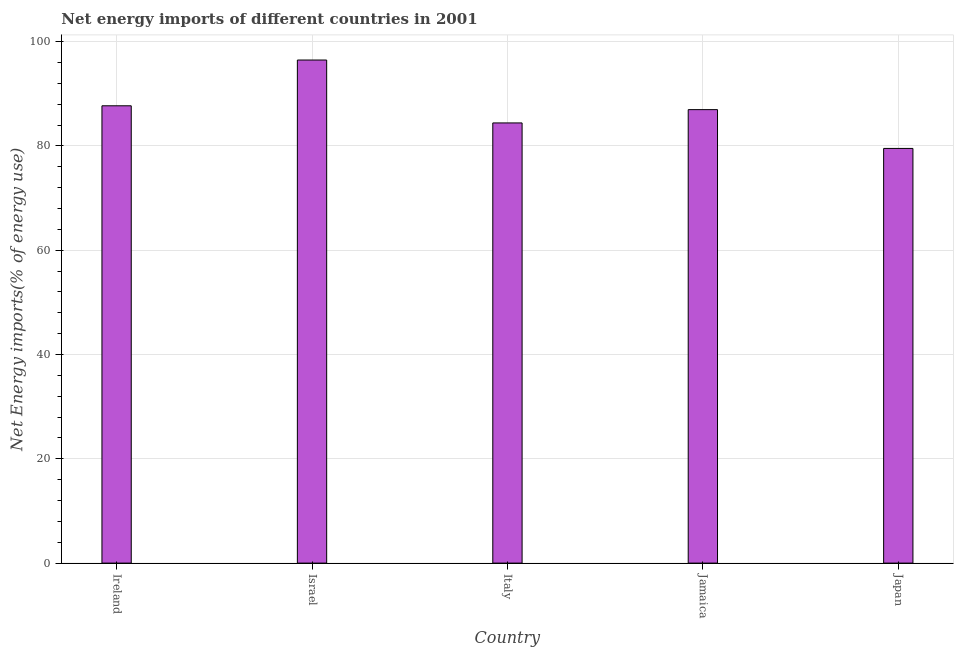Does the graph contain any zero values?
Your response must be concise. No. What is the title of the graph?
Provide a short and direct response. Net energy imports of different countries in 2001. What is the label or title of the Y-axis?
Offer a very short reply. Net Energy imports(% of energy use). What is the energy imports in Jamaica?
Offer a very short reply. 86.97. Across all countries, what is the maximum energy imports?
Ensure brevity in your answer.  96.49. Across all countries, what is the minimum energy imports?
Provide a succinct answer. 79.53. In which country was the energy imports maximum?
Give a very brief answer. Israel. In which country was the energy imports minimum?
Your response must be concise. Japan. What is the sum of the energy imports?
Provide a succinct answer. 435.12. What is the difference between the energy imports in Ireland and Italy?
Ensure brevity in your answer.  3.29. What is the average energy imports per country?
Give a very brief answer. 87.02. What is the median energy imports?
Offer a very short reply. 86.97. What is the ratio of the energy imports in Ireland to that in Italy?
Provide a short and direct response. 1.04. What is the difference between the highest and the second highest energy imports?
Provide a succinct answer. 8.78. Is the sum of the energy imports in Israel and Japan greater than the maximum energy imports across all countries?
Give a very brief answer. Yes. What is the difference between the highest and the lowest energy imports?
Your answer should be very brief. 16.96. Are all the bars in the graph horizontal?
Your answer should be compact. No. How many countries are there in the graph?
Your answer should be compact. 5. What is the difference between two consecutive major ticks on the Y-axis?
Offer a very short reply. 20. What is the Net Energy imports(% of energy use) in Ireland?
Ensure brevity in your answer.  87.71. What is the Net Energy imports(% of energy use) in Israel?
Give a very brief answer. 96.49. What is the Net Energy imports(% of energy use) of Italy?
Your answer should be compact. 84.42. What is the Net Energy imports(% of energy use) of Jamaica?
Offer a terse response. 86.97. What is the Net Energy imports(% of energy use) in Japan?
Give a very brief answer. 79.53. What is the difference between the Net Energy imports(% of energy use) in Ireland and Israel?
Give a very brief answer. -8.78. What is the difference between the Net Energy imports(% of energy use) in Ireland and Italy?
Make the answer very short. 3.29. What is the difference between the Net Energy imports(% of energy use) in Ireland and Jamaica?
Provide a succinct answer. 0.73. What is the difference between the Net Energy imports(% of energy use) in Ireland and Japan?
Keep it short and to the point. 8.18. What is the difference between the Net Energy imports(% of energy use) in Israel and Italy?
Keep it short and to the point. 12.06. What is the difference between the Net Energy imports(% of energy use) in Israel and Jamaica?
Give a very brief answer. 9.51. What is the difference between the Net Energy imports(% of energy use) in Israel and Japan?
Your answer should be very brief. 16.96. What is the difference between the Net Energy imports(% of energy use) in Italy and Jamaica?
Your answer should be very brief. -2.55. What is the difference between the Net Energy imports(% of energy use) in Italy and Japan?
Offer a terse response. 4.89. What is the difference between the Net Energy imports(% of energy use) in Jamaica and Japan?
Your answer should be compact. 7.44. What is the ratio of the Net Energy imports(% of energy use) in Ireland to that in Israel?
Your answer should be compact. 0.91. What is the ratio of the Net Energy imports(% of energy use) in Ireland to that in Italy?
Your response must be concise. 1.04. What is the ratio of the Net Energy imports(% of energy use) in Ireland to that in Jamaica?
Keep it short and to the point. 1.01. What is the ratio of the Net Energy imports(% of energy use) in Ireland to that in Japan?
Provide a succinct answer. 1.1. What is the ratio of the Net Energy imports(% of energy use) in Israel to that in Italy?
Keep it short and to the point. 1.14. What is the ratio of the Net Energy imports(% of energy use) in Israel to that in Jamaica?
Your answer should be very brief. 1.11. What is the ratio of the Net Energy imports(% of energy use) in Israel to that in Japan?
Your answer should be very brief. 1.21. What is the ratio of the Net Energy imports(% of energy use) in Italy to that in Japan?
Your answer should be compact. 1.06. What is the ratio of the Net Energy imports(% of energy use) in Jamaica to that in Japan?
Make the answer very short. 1.09. 